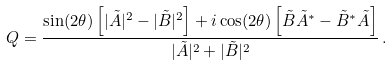<formula> <loc_0><loc_0><loc_500><loc_500>Q = \frac { \sin ( 2 \theta ) \left [ | \tilde { A } | ^ { 2 } - | \tilde { B } | ^ { 2 } \right ] + i \cos ( 2 \theta ) \left [ \tilde { B } \tilde { A } ^ { * } - \tilde { B } ^ { * } \tilde { A } \right ] } { | \tilde { A } | ^ { 2 } + | \tilde { B } | ^ { 2 } } \, .</formula> 